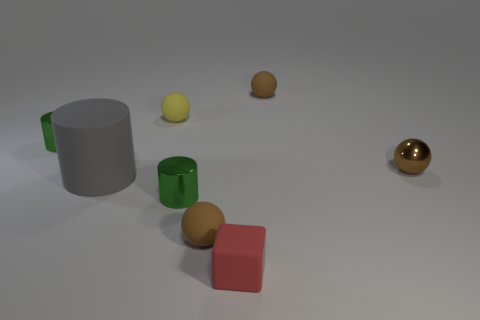How many brown spheres must be subtracted to get 1 brown spheres? 2 Subtract all tiny metallic balls. How many balls are left? 3 Subtract all cubes. How many objects are left? 7 Subtract all yellow spheres. How many spheres are left? 3 Add 1 green cylinders. How many objects exist? 9 Subtract all red balls. How many gray cylinders are left? 1 Subtract all tiny yellow spheres. Subtract all tiny yellow matte things. How many objects are left? 6 Add 7 green objects. How many green objects are left? 9 Add 2 cylinders. How many cylinders exist? 5 Subtract 1 yellow spheres. How many objects are left? 7 